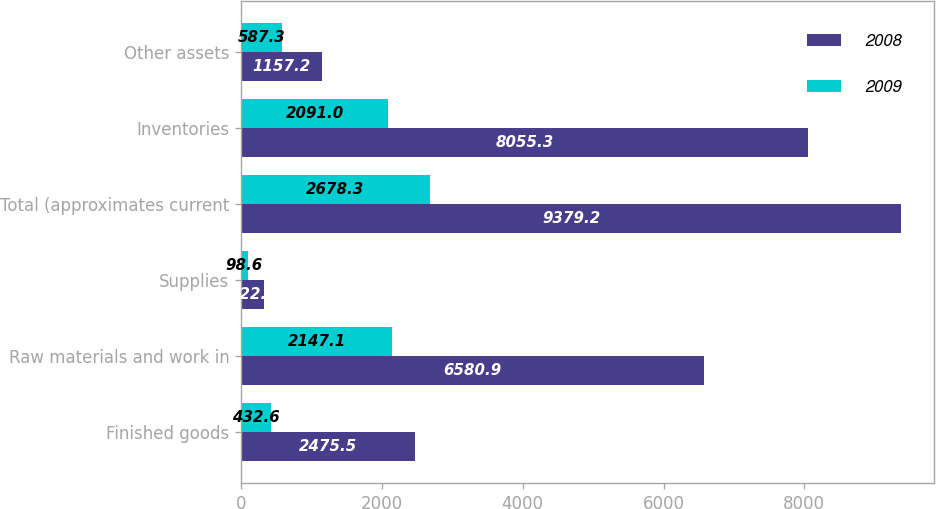Convert chart to OTSL. <chart><loc_0><loc_0><loc_500><loc_500><stacked_bar_chart><ecel><fcel>Finished goods<fcel>Raw materials and work in<fcel>Supplies<fcel>Total (approximates current<fcel>Inventories<fcel>Other assets<nl><fcel>2008<fcel>2475.5<fcel>6580.9<fcel>322.8<fcel>9379.2<fcel>8055.3<fcel>1157.2<nl><fcel>2009<fcel>432.6<fcel>2147.1<fcel>98.6<fcel>2678.3<fcel>2091<fcel>587.3<nl></chart> 